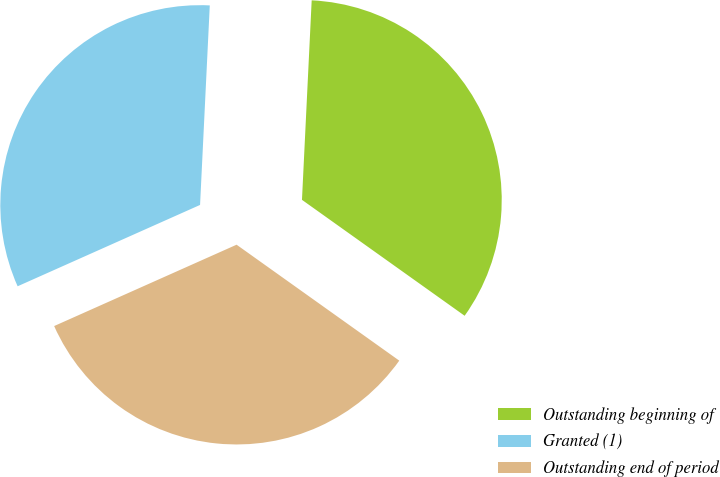<chart> <loc_0><loc_0><loc_500><loc_500><pie_chart><fcel>Outstanding beginning of<fcel>Granted (1)<fcel>Outstanding end of period<nl><fcel>34.08%<fcel>32.45%<fcel>33.47%<nl></chart> 